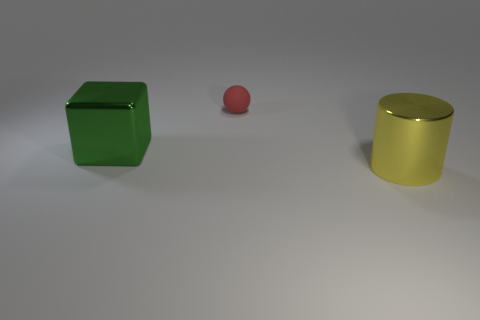Can you tell me what the objects are made of? Based on the image, the objects appear to be three-dimensional renderings with surfaces that simulate materials like glossy painted metal or plastic. However, without more context or information, it’s not possible to determine the exact materials. 